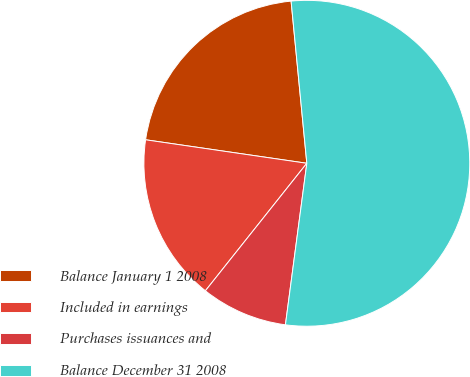Convert chart to OTSL. <chart><loc_0><loc_0><loc_500><loc_500><pie_chart><fcel>Balance January 1 2008<fcel>Included in earnings<fcel>Purchases issuances and<fcel>Balance December 31 2008<nl><fcel>21.16%<fcel>16.61%<fcel>8.6%<fcel>53.64%<nl></chart> 